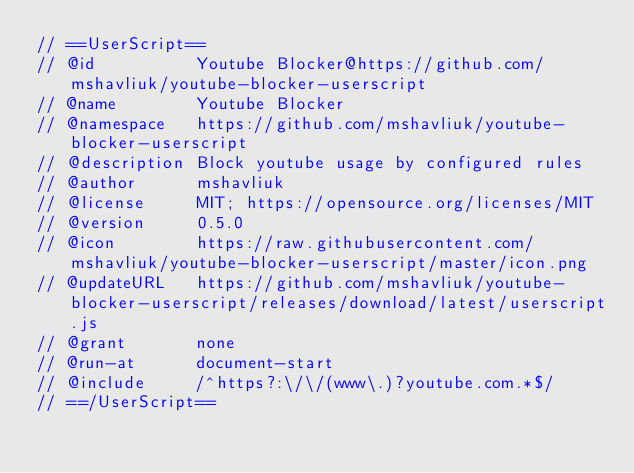Convert code to text. <code><loc_0><loc_0><loc_500><loc_500><_JavaScript_>// ==UserScript==
// @id          Youtube Blocker@https://github.com/mshavliuk/youtube-blocker-userscript
// @name        Youtube Blocker
// @namespace   https://github.com/mshavliuk/youtube-blocker-userscript
// @description Block youtube usage by configured rules
// @author      mshavliuk
// @license     MIT; https://opensource.org/licenses/MIT
// @version     0.5.0
// @icon        https://raw.githubusercontent.com/mshavliuk/youtube-blocker-userscript/master/icon.png
// @updateURL   https://github.com/mshavliuk/youtube-blocker-userscript/releases/download/latest/userscript.js
// @grant       none
// @run-at      document-start
// @include     /^https?:\/\/(www\.)?youtube.com.*$/
// ==/UserScript==
</code> 